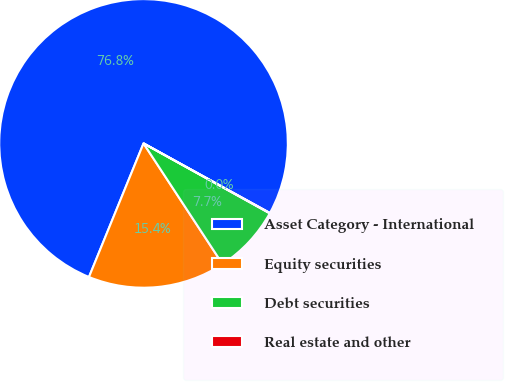<chart> <loc_0><loc_0><loc_500><loc_500><pie_chart><fcel>Asset Category - International<fcel>Equity securities<fcel>Debt securities<fcel>Real estate and other<nl><fcel>76.84%<fcel>15.4%<fcel>7.72%<fcel>0.04%<nl></chart> 